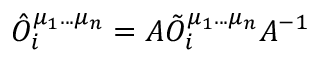Convert formula to latex. <formula><loc_0><loc_0><loc_500><loc_500>{ \hat { O } } _ { i } ^ { \mu _ { 1 } \dots \mu _ { n } } = A { \tilde { O } } _ { i } ^ { \mu _ { 1 } \dots \mu _ { n } } A ^ { - 1 }</formula> 